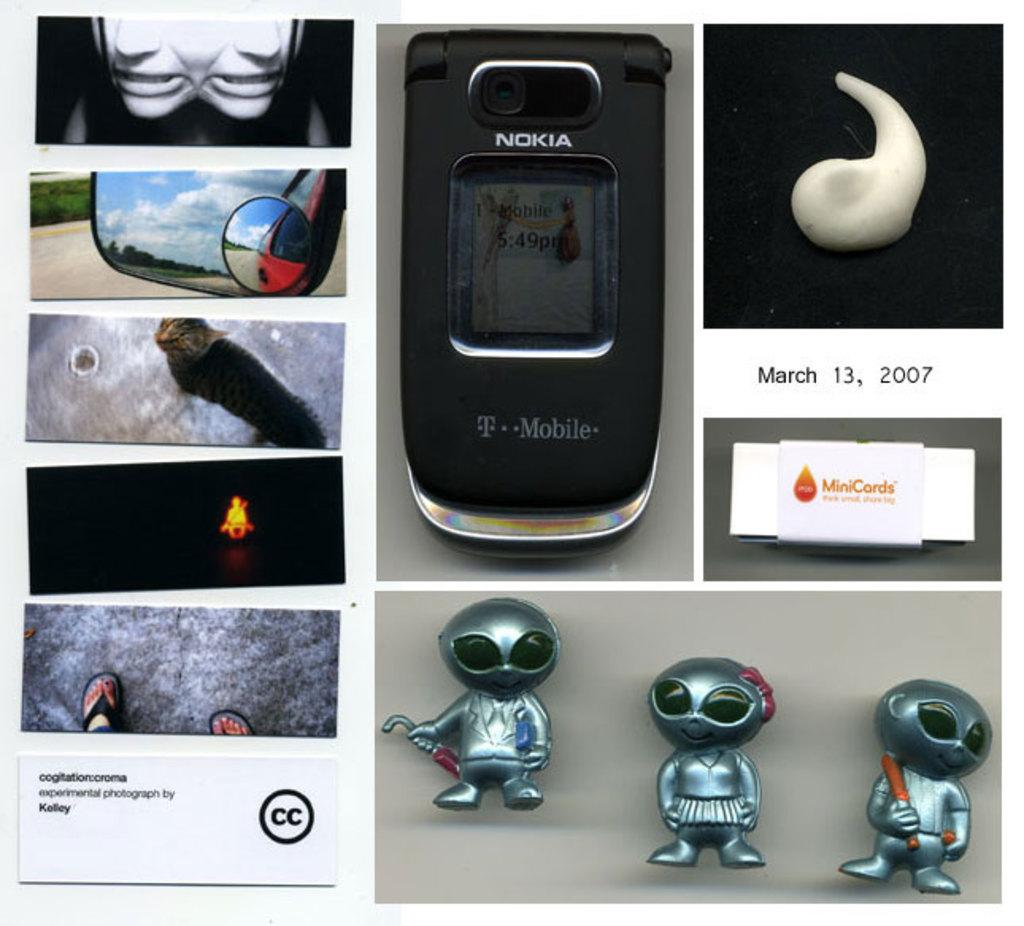<image>
Create a compact narrative representing the image presented. A Nokia cell phone that was made by T-Mobile. 